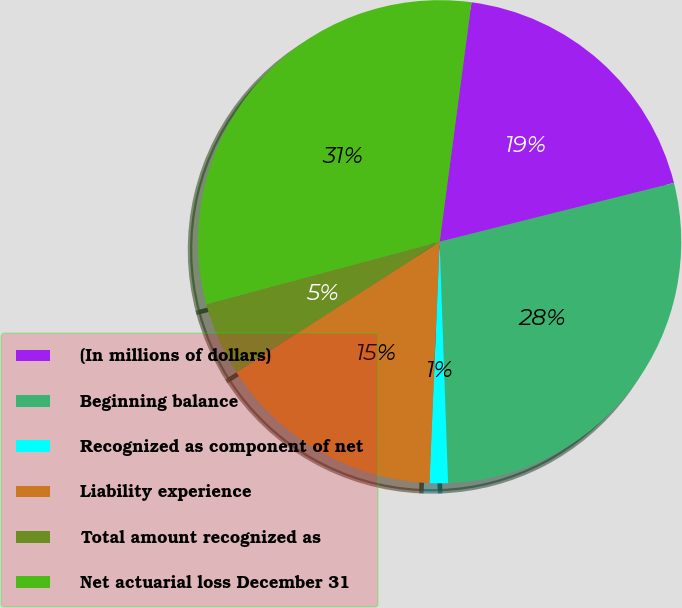Convert chart to OTSL. <chart><loc_0><loc_0><loc_500><loc_500><pie_chart><fcel>(In millions of dollars)<fcel>Beginning balance<fcel>Recognized as component of net<fcel>Liability experience<fcel>Total amount recognized as<fcel>Net actuarial loss December 31<nl><fcel>18.98%<fcel>28.36%<fcel>1.23%<fcel>15.25%<fcel>4.91%<fcel>31.27%<nl></chart> 